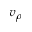Convert formula to latex. <formula><loc_0><loc_0><loc_500><loc_500>v _ { \rho }</formula> 